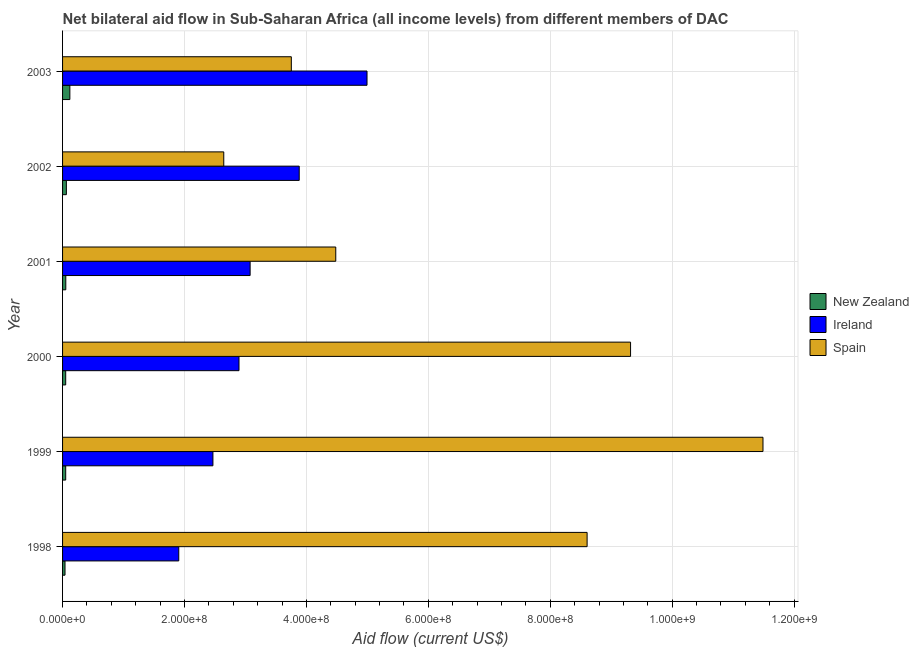How many bars are there on the 3rd tick from the bottom?
Your answer should be compact. 3. What is the label of the 5th group of bars from the top?
Offer a very short reply. 1999. What is the amount of aid provided by new zealand in 1999?
Ensure brevity in your answer.  5.15e+06. Across all years, what is the maximum amount of aid provided by new zealand?
Give a very brief answer. 1.20e+07. Across all years, what is the minimum amount of aid provided by ireland?
Offer a very short reply. 1.91e+08. In which year was the amount of aid provided by spain maximum?
Provide a succinct answer. 1999. What is the total amount of aid provided by ireland in the graph?
Provide a succinct answer. 1.92e+09. What is the difference between the amount of aid provided by ireland in 1999 and that in 2003?
Your answer should be very brief. -2.53e+08. What is the difference between the amount of aid provided by ireland in 2000 and the amount of aid provided by spain in 2002?
Ensure brevity in your answer.  2.50e+07. What is the average amount of aid provided by new zealand per year?
Your response must be concise. 6.30e+06. In the year 1998, what is the difference between the amount of aid provided by ireland and amount of aid provided by new zealand?
Your response must be concise. 1.87e+08. What is the ratio of the amount of aid provided by new zealand in 1999 to that in 2000?
Keep it short and to the point. 1. Is the difference between the amount of aid provided by ireland in 2001 and 2003 greater than the difference between the amount of aid provided by new zealand in 2001 and 2003?
Make the answer very short. No. What is the difference between the highest and the second highest amount of aid provided by spain?
Your answer should be compact. 2.17e+08. What is the difference between the highest and the lowest amount of aid provided by new zealand?
Your answer should be compact. 7.94e+06. In how many years, is the amount of aid provided by ireland greater than the average amount of aid provided by ireland taken over all years?
Offer a very short reply. 2. Is the sum of the amount of aid provided by new zealand in 1998 and 1999 greater than the maximum amount of aid provided by ireland across all years?
Keep it short and to the point. No. What does the 1st bar from the bottom in 1998 represents?
Make the answer very short. New Zealand. Is it the case that in every year, the sum of the amount of aid provided by new zealand and amount of aid provided by ireland is greater than the amount of aid provided by spain?
Provide a short and direct response. No. What is the difference between two consecutive major ticks on the X-axis?
Give a very brief answer. 2.00e+08. Does the graph contain grids?
Keep it short and to the point. Yes. How are the legend labels stacked?
Your answer should be very brief. Vertical. What is the title of the graph?
Ensure brevity in your answer.  Net bilateral aid flow in Sub-Saharan Africa (all income levels) from different members of DAC. What is the label or title of the X-axis?
Provide a short and direct response. Aid flow (current US$). What is the Aid flow (current US$) of New Zealand in 1998?
Ensure brevity in your answer.  4.02e+06. What is the Aid flow (current US$) in Ireland in 1998?
Keep it short and to the point. 1.91e+08. What is the Aid flow (current US$) in Spain in 1998?
Your answer should be very brief. 8.60e+08. What is the Aid flow (current US$) in New Zealand in 1999?
Your answer should be compact. 5.15e+06. What is the Aid flow (current US$) of Ireland in 1999?
Give a very brief answer. 2.47e+08. What is the Aid flow (current US$) of Spain in 1999?
Give a very brief answer. 1.15e+09. What is the Aid flow (current US$) in New Zealand in 2000?
Your answer should be compact. 5.14e+06. What is the Aid flow (current US$) of Ireland in 2000?
Give a very brief answer. 2.89e+08. What is the Aid flow (current US$) in Spain in 2000?
Ensure brevity in your answer.  9.32e+08. What is the Aid flow (current US$) of New Zealand in 2001?
Give a very brief answer. 5.29e+06. What is the Aid flow (current US$) in Ireland in 2001?
Your response must be concise. 3.08e+08. What is the Aid flow (current US$) in Spain in 2001?
Provide a succinct answer. 4.48e+08. What is the Aid flow (current US$) of New Zealand in 2002?
Ensure brevity in your answer.  6.26e+06. What is the Aid flow (current US$) in Ireland in 2002?
Make the answer very short. 3.88e+08. What is the Aid flow (current US$) in Spain in 2002?
Ensure brevity in your answer.  2.64e+08. What is the Aid flow (current US$) in New Zealand in 2003?
Offer a very short reply. 1.20e+07. What is the Aid flow (current US$) in Ireland in 2003?
Offer a very short reply. 4.99e+08. What is the Aid flow (current US$) of Spain in 2003?
Give a very brief answer. 3.75e+08. Across all years, what is the maximum Aid flow (current US$) of New Zealand?
Keep it short and to the point. 1.20e+07. Across all years, what is the maximum Aid flow (current US$) of Ireland?
Ensure brevity in your answer.  4.99e+08. Across all years, what is the maximum Aid flow (current US$) in Spain?
Your answer should be very brief. 1.15e+09. Across all years, what is the minimum Aid flow (current US$) in New Zealand?
Offer a very short reply. 4.02e+06. Across all years, what is the minimum Aid flow (current US$) of Ireland?
Offer a very short reply. 1.91e+08. Across all years, what is the minimum Aid flow (current US$) of Spain?
Give a very brief answer. 2.64e+08. What is the total Aid flow (current US$) in New Zealand in the graph?
Offer a very short reply. 3.78e+07. What is the total Aid flow (current US$) of Ireland in the graph?
Provide a succinct answer. 1.92e+09. What is the total Aid flow (current US$) in Spain in the graph?
Provide a succinct answer. 4.03e+09. What is the difference between the Aid flow (current US$) of New Zealand in 1998 and that in 1999?
Your response must be concise. -1.13e+06. What is the difference between the Aid flow (current US$) in Ireland in 1998 and that in 1999?
Provide a succinct answer. -5.60e+07. What is the difference between the Aid flow (current US$) of Spain in 1998 and that in 1999?
Offer a terse response. -2.88e+08. What is the difference between the Aid flow (current US$) in New Zealand in 1998 and that in 2000?
Make the answer very short. -1.12e+06. What is the difference between the Aid flow (current US$) of Ireland in 1998 and that in 2000?
Keep it short and to the point. -9.88e+07. What is the difference between the Aid flow (current US$) in Spain in 1998 and that in 2000?
Keep it short and to the point. -7.13e+07. What is the difference between the Aid flow (current US$) in New Zealand in 1998 and that in 2001?
Offer a very short reply. -1.27e+06. What is the difference between the Aid flow (current US$) of Ireland in 1998 and that in 2001?
Provide a succinct answer. -1.17e+08. What is the difference between the Aid flow (current US$) in Spain in 1998 and that in 2001?
Provide a succinct answer. 4.12e+08. What is the difference between the Aid flow (current US$) in New Zealand in 1998 and that in 2002?
Offer a very short reply. -2.24e+06. What is the difference between the Aid flow (current US$) in Ireland in 1998 and that in 2002?
Ensure brevity in your answer.  -1.98e+08. What is the difference between the Aid flow (current US$) of Spain in 1998 and that in 2002?
Make the answer very short. 5.96e+08. What is the difference between the Aid flow (current US$) in New Zealand in 1998 and that in 2003?
Provide a succinct answer. -7.94e+06. What is the difference between the Aid flow (current US$) in Ireland in 1998 and that in 2003?
Ensure brevity in your answer.  -3.09e+08. What is the difference between the Aid flow (current US$) in Spain in 1998 and that in 2003?
Your answer should be very brief. 4.85e+08. What is the difference between the Aid flow (current US$) of New Zealand in 1999 and that in 2000?
Offer a terse response. 10000. What is the difference between the Aid flow (current US$) in Ireland in 1999 and that in 2000?
Keep it short and to the point. -4.28e+07. What is the difference between the Aid flow (current US$) of Spain in 1999 and that in 2000?
Your answer should be compact. 2.17e+08. What is the difference between the Aid flow (current US$) of Ireland in 1999 and that in 2001?
Provide a short and direct response. -6.10e+07. What is the difference between the Aid flow (current US$) in Spain in 1999 and that in 2001?
Offer a terse response. 7.01e+08. What is the difference between the Aid flow (current US$) of New Zealand in 1999 and that in 2002?
Offer a terse response. -1.11e+06. What is the difference between the Aid flow (current US$) of Ireland in 1999 and that in 2002?
Offer a very short reply. -1.42e+08. What is the difference between the Aid flow (current US$) in Spain in 1999 and that in 2002?
Your response must be concise. 8.84e+08. What is the difference between the Aid flow (current US$) of New Zealand in 1999 and that in 2003?
Make the answer very short. -6.81e+06. What is the difference between the Aid flow (current US$) in Ireland in 1999 and that in 2003?
Provide a short and direct response. -2.53e+08. What is the difference between the Aid flow (current US$) of Spain in 1999 and that in 2003?
Offer a terse response. 7.74e+08. What is the difference between the Aid flow (current US$) of New Zealand in 2000 and that in 2001?
Make the answer very short. -1.50e+05. What is the difference between the Aid flow (current US$) in Ireland in 2000 and that in 2001?
Ensure brevity in your answer.  -1.82e+07. What is the difference between the Aid flow (current US$) of Spain in 2000 and that in 2001?
Provide a short and direct response. 4.84e+08. What is the difference between the Aid flow (current US$) of New Zealand in 2000 and that in 2002?
Provide a short and direct response. -1.12e+06. What is the difference between the Aid flow (current US$) in Ireland in 2000 and that in 2002?
Provide a short and direct response. -9.88e+07. What is the difference between the Aid flow (current US$) in Spain in 2000 and that in 2002?
Your answer should be very brief. 6.67e+08. What is the difference between the Aid flow (current US$) of New Zealand in 2000 and that in 2003?
Your answer should be very brief. -6.82e+06. What is the difference between the Aid flow (current US$) of Ireland in 2000 and that in 2003?
Keep it short and to the point. -2.10e+08. What is the difference between the Aid flow (current US$) of Spain in 2000 and that in 2003?
Keep it short and to the point. 5.56e+08. What is the difference between the Aid flow (current US$) of New Zealand in 2001 and that in 2002?
Provide a succinct answer. -9.70e+05. What is the difference between the Aid flow (current US$) in Ireland in 2001 and that in 2002?
Your answer should be compact. -8.05e+07. What is the difference between the Aid flow (current US$) in Spain in 2001 and that in 2002?
Ensure brevity in your answer.  1.84e+08. What is the difference between the Aid flow (current US$) of New Zealand in 2001 and that in 2003?
Offer a very short reply. -6.67e+06. What is the difference between the Aid flow (current US$) of Ireland in 2001 and that in 2003?
Make the answer very short. -1.92e+08. What is the difference between the Aid flow (current US$) in Spain in 2001 and that in 2003?
Your answer should be compact. 7.29e+07. What is the difference between the Aid flow (current US$) in New Zealand in 2002 and that in 2003?
Ensure brevity in your answer.  -5.70e+06. What is the difference between the Aid flow (current US$) in Ireland in 2002 and that in 2003?
Your answer should be very brief. -1.11e+08. What is the difference between the Aid flow (current US$) in Spain in 2002 and that in 2003?
Keep it short and to the point. -1.11e+08. What is the difference between the Aid flow (current US$) in New Zealand in 1998 and the Aid flow (current US$) in Ireland in 1999?
Offer a very short reply. -2.43e+08. What is the difference between the Aid flow (current US$) in New Zealand in 1998 and the Aid flow (current US$) in Spain in 1999?
Provide a short and direct response. -1.14e+09. What is the difference between the Aid flow (current US$) in Ireland in 1998 and the Aid flow (current US$) in Spain in 1999?
Give a very brief answer. -9.58e+08. What is the difference between the Aid flow (current US$) in New Zealand in 1998 and the Aid flow (current US$) in Ireland in 2000?
Your answer should be very brief. -2.85e+08. What is the difference between the Aid flow (current US$) in New Zealand in 1998 and the Aid flow (current US$) in Spain in 2000?
Provide a succinct answer. -9.28e+08. What is the difference between the Aid flow (current US$) of Ireland in 1998 and the Aid flow (current US$) of Spain in 2000?
Give a very brief answer. -7.41e+08. What is the difference between the Aid flow (current US$) in New Zealand in 1998 and the Aid flow (current US$) in Ireland in 2001?
Provide a short and direct response. -3.04e+08. What is the difference between the Aid flow (current US$) of New Zealand in 1998 and the Aid flow (current US$) of Spain in 2001?
Keep it short and to the point. -4.44e+08. What is the difference between the Aid flow (current US$) in Ireland in 1998 and the Aid flow (current US$) in Spain in 2001?
Your answer should be compact. -2.58e+08. What is the difference between the Aid flow (current US$) of New Zealand in 1998 and the Aid flow (current US$) of Ireland in 2002?
Keep it short and to the point. -3.84e+08. What is the difference between the Aid flow (current US$) in New Zealand in 1998 and the Aid flow (current US$) in Spain in 2002?
Your answer should be compact. -2.60e+08. What is the difference between the Aid flow (current US$) of Ireland in 1998 and the Aid flow (current US$) of Spain in 2002?
Keep it short and to the point. -7.38e+07. What is the difference between the Aid flow (current US$) in New Zealand in 1998 and the Aid flow (current US$) in Ireland in 2003?
Give a very brief answer. -4.95e+08. What is the difference between the Aid flow (current US$) of New Zealand in 1998 and the Aid flow (current US$) of Spain in 2003?
Your answer should be compact. -3.71e+08. What is the difference between the Aid flow (current US$) of Ireland in 1998 and the Aid flow (current US$) of Spain in 2003?
Ensure brevity in your answer.  -1.85e+08. What is the difference between the Aid flow (current US$) of New Zealand in 1999 and the Aid flow (current US$) of Ireland in 2000?
Offer a terse response. -2.84e+08. What is the difference between the Aid flow (current US$) of New Zealand in 1999 and the Aid flow (current US$) of Spain in 2000?
Ensure brevity in your answer.  -9.27e+08. What is the difference between the Aid flow (current US$) of Ireland in 1999 and the Aid flow (current US$) of Spain in 2000?
Offer a terse response. -6.85e+08. What is the difference between the Aid flow (current US$) of New Zealand in 1999 and the Aid flow (current US$) of Ireland in 2001?
Ensure brevity in your answer.  -3.03e+08. What is the difference between the Aid flow (current US$) of New Zealand in 1999 and the Aid flow (current US$) of Spain in 2001?
Your response must be concise. -4.43e+08. What is the difference between the Aid flow (current US$) in Ireland in 1999 and the Aid flow (current US$) in Spain in 2001?
Make the answer very short. -2.02e+08. What is the difference between the Aid flow (current US$) of New Zealand in 1999 and the Aid flow (current US$) of Ireland in 2002?
Offer a terse response. -3.83e+08. What is the difference between the Aid flow (current US$) in New Zealand in 1999 and the Aid flow (current US$) in Spain in 2002?
Provide a short and direct response. -2.59e+08. What is the difference between the Aid flow (current US$) in Ireland in 1999 and the Aid flow (current US$) in Spain in 2002?
Your answer should be very brief. -1.78e+07. What is the difference between the Aid flow (current US$) in New Zealand in 1999 and the Aid flow (current US$) in Ireland in 2003?
Your answer should be compact. -4.94e+08. What is the difference between the Aid flow (current US$) in New Zealand in 1999 and the Aid flow (current US$) in Spain in 2003?
Offer a terse response. -3.70e+08. What is the difference between the Aid flow (current US$) of Ireland in 1999 and the Aid flow (current US$) of Spain in 2003?
Offer a terse response. -1.29e+08. What is the difference between the Aid flow (current US$) of New Zealand in 2000 and the Aid flow (current US$) of Ireland in 2001?
Keep it short and to the point. -3.03e+08. What is the difference between the Aid flow (current US$) in New Zealand in 2000 and the Aid flow (current US$) in Spain in 2001?
Offer a terse response. -4.43e+08. What is the difference between the Aid flow (current US$) in Ireland in 2000 and the Aid flow (current US$) in Spain in 2001?
Offer a terse response. -1.59e+08. What is the difference between the Aid flow (current US$) of New Zealand in 2000 and the Aid flow (current US$) of Ireland in 2002?
Ensure brevity in your answer.  -3.83e+08. What is the difference between the Aid flow (current US$) of New Zealand in 2000 and the Aid flow (current US$) of Spain in 2002?
Ensure brevity in your answer.  -2.59e+08. What is the difference between the Aid flow (current US$) in Ireland in 2000 and the Aid flow (current US$) in Spain in 2002?
Your answer should be very brief. 2.50e+07. What is the difference between the Aid flow (current US$) of New Zealand in 2000 and the Aid flow (current US$) of Ireland in 2003?
Provide a short and direct response. -4.94e+08. What is the difference between the Aid flow (current US$) of New Zealand in 2000 and the Aid flow (current US$) of Spain in 2003?
Keep it short and to the point. -3.70e+08. What is the difference between the Aid flow (current US$) in Ireland in 2000 and the Aid flow (current US$) in Spain in 2003?
Ensure brevity in your answer.  -8.58e+07. What is the difference between the Aid flow (current US$) of New Zealand in 2001 and the Aid flow (current US$) of Ireland in 2002?
Your answer should be very brief. -3.83e+08. What is the difference between the Aid flow (current US$) of New Zealand in 2001 and the Aid flow (current US$) of Spain in 2002?
Your answer should be compact. -2.59e+08. What is the difference between the Aid flow (current US$) of Ireland in 2001 and the Aid flow (current US$) of Spain in 2002?
Your answer should be very brief. 4.32e+07. What is the difference between the Aid flow (current US$) in New Zealand in 2001 and the Aid flow (current US$) in Ireland in 2003?
Your answer should be very brief. -4.94e+08. What is the difference between the Aid flow (current US$) of New Zealand in 2001 and the Aid flow (current US$) of Spain in 2003?
Keep it short and to the point. -3.70e+08. What is the difference between the Aid flow (current US$) in Ireland in 2001 and the Aid flow (current US$) in Spain in 2003?
Ensure brevity in your answer.  -6.76e+07. What is the difference between the Aid flow (current US$) of New Zealand in 2002 and the Aid flow (current US$) of Ireland in 2003?
Offer a very short reply. -4.93e+08. What is the difference between the Aid flow (current US$) in New Zealand in 2002 and the Aid flow (current US$) in Spain in 2003?
Provide a succinct answer. -3.69e+08. What is the difference between the Aid flow (current US$) in Ireland in 2002 and the Aid flow (current US$) in Spain in 2003?
Offer a terse response. 1.30e+07. What is the average Aid flow (current US$) in New Zealand per year?
Your answer should be compact. 6.30e+06. What is the average Aid flow (current US$) in Ireland per year?
Provide a succinct answer. 3.20e+08. What is the average Aid flow (current US$) of Spain per year?
Offer a terse response. 6.71e+08. In the year 1998, what is the difference between the Aid flow (current US$) of New Zealand and Aid flow (current US$) of Ireland?
Provide a short and direct response. -1.87e+08. In the year 1998, what is the difference between the Aid flow (current US$) in New Zealand and Aid flow (current US$) in Spain?
Your response must be concise. -8.56e+08. In the year 1998, what is the difference between the Aid flow (current US$) in Ireland and Aid flow (current US$) in Spain?
Provide a succinct answer. -6.70e+08. In the year 1999, what is the difference between the Aid flow (current US$) of New Zealand and Aid flow (current US$) of Ireland?
Offer a very short reply. -2.41e+08. In the year 1999, what is the difference between the Aid flow (current US$) in New Zealand and Aid flow (current US$) in Spain?
Give a very brief answer. -1.14e+09. In the year 1999, what is the difference between the Aid flow (current US$) of Ireland and Aid flow (current US$) of Spain?
Give a very brief answer. -9.02e+08. In the year 2000, what is the difference between the Aid flow (current US$) in New Zealand and Aid flow (current US$) in Ireland?
Your response must be concise. -2.84e+08. In the year 2000, what is the difference between the Aid flow (current US$) in New Zealand and Aid flow (current US$) in Spain?
Make the answer very short. -9.27e+08. In the year 2000, what is the difference between the Aid flow (current US$) of Ireland and Aid flow (current US$) of Spain?
Give a very brief answer. -6.42e+08. In the year 2001, what is the difference between the Aid flow (current US$) of New Zealand and Aid flow (current US$) of Ireland?
Offer a very short reply. -3.02e+08. In the year 2001, what is the difference between the Aid flow (current US$) of New Zealand and Aid flow (current US$) of Spain?
Provide a succinct answer. -4.43e+08. In the year 2001, what is the difference between the Aid flow (current US$) of Ireland and Aid flow (current US$) of Spain?
Offer a very short reply. -1.40e+08. In the year 2002, what is the difference between the Aid flow (current US$) in New Zealand and Aid flow (current US$) in Ireland?
Offer a very short reply. -3.82e+08. In the year 2002, what is the difference between the Aid flow (current US$) of New Zealand and Aid flow (current US$) of Spain?
Your answer should be compact. -2.58e+08. In the year 2002, what is the difference between the Aid flow (current US$) of Ireland and Aid flow (current US$) of Spain?
Offer a very short reply. 1.24e+08. In the year 2003, what is the difference between the Aid flow (current US$) in New Zealand and Aid flow (current US$) in Ireland?
Provide a short and direct response. -4.87e+08. In the year 2003, what is the difference between the Aid flow (current US$) of New Zealand and Aid flow (current US$) of Spain?
Ensure brevity in your answer.  -3.63e+08. In the year 2003, what is the difference between the Aid flow (current US$) in Ireland and Aid flow (current US$) in Spain?
Offer a very short reply. 1.24e+08. What is the ratio of the Aid flow (current US$) of New Zealand in 1998 to that in 1999?
Offer a terse response. 0.78. What is the ratio of the Aid flow (current US$) of Ireland in 1998 to that in 1999?
Give a very brief answer. 0.77. What is the ratio of the Aid flow (current US$) of Spain in 1998 to that in 1999?
Offer a very short reply. 0.75. What is the ratio of the Aid flow (current US$) in New Zealand in 1998 to that in 2000?
Your response must be concise. 0.78. What is the ratio of the Aid flow (current US$) in Ireland in 1998 to that in 2000?
Offer a very short reply. 0.66. What is the ratio of the Aid flow (current US$) of Spain in 1998 to that in 2000?
Offer a very short reply. 0.92. What is the ratio of the Aid flow (current US$) of New Zealand in 1998 to that in 2001?
Keep it short and to the point. 0.76. What is the ratio of the Aid flow (current US$) of Ireland in 1998 to that in 2001?
Give a very brief answer. 0.62. What is the ratio of the Aid flow (current US$) of Spain in 1998 to that in 2001?
Your answer should be compact. 1.92. What is the ratio of the Aid flow (current US$) of New Zealand in 1998 to that in 2002?
Your answer should be very brief. 0.64. What is the ratio of the Aid flow (current US$) in Ireland in 1998 to that in 2002?
Provide a succinct answer. 0.49. What is the ratio of the Aid flow (current US$) in Spain in 1998 to that in 2002?
Ensure brevity in your answer.  3.25. What is the ratio of the Aid flow (current US$) in New Zealand in 1998 to that in 2003?
Offer a terse response. 0.34. What is the ratio of the Aid flow (current US$) in Ireland in 1998 to that in 2003?
Offer a terse response. 0.38. What is the ratio of the Aid flow (current US$) of Spain in 1998 to that in 2003?
Your answer should be compact. 2.29. What is the ratio of the Aid flow (current US$) in Ireland in 1999 to that in 2000?
Give a very brief answer. 0.85. What is the ratio of the Aid flow (current US$) in Spain in 1999 to that in 2000?
Make the answer very short. 1.23. What is the ratio of the Aid flow (current US$) in New Zealand in 1999 to that in 2001?
Provide a short and direct response. 0.97. What is the ratio of the Aid flow (current US$) of Ireland in 1999 to that in 2001?
Give a very brief answer. 0.8. What is the ratio of the Aid flow (current US$) of Spain in 1999 to that in 2001?
Offer a terse response. 2.56. What is the ratio of the Aid flow (current US$) of New Zealand in 1999 to that in 2002?
Keep it short and to the point. 0.82. What is the ratio of the Aid flow (current US$) of Ireland in 1999 to that in 2002?
Provide a succinct answer. 0.64. What is the ratio of the Aid flow (current US$) in Spain in 1999 to that in 2002?
Ensure brevity in your answer.  4.34. What is the ratio of the Aid flow (current US$) in New Zealand in 1999 to that in 2003?
Make the answer very short. 0.43. What is the ratio of the Aid flow (current US$) in Ireland in 1999 to that in 2003?
Your response must be concise. 0.49. What is the ratio of the Aid flow (current US$) in Spain in 1999 to that in 2003?
Ensure brevity in your answer.  3.06. What is the ratio of the Aid flow (current US$) of New Zealand in 2000 to that in 2001?
Make the answer very short. 0.97. What is the ratio of the Aid flow (current US$) of Ireland in 2000 to that in 2001?
Offer a very short reply. 0.94. What is the ratio of the Aid flow (current US$) of Spain in 2000 to that in 2001?
Offer a very short reply. 2.08. What is the ratio of the Aid flow (current US$) of New Zealand in 2000 to that in 2002?
Your answer should be compact. 0.82. What is the ratio of the Aid flow (current US$) of Ireland in 2000 to that in 2002?
Your answer should be very brief. 0.75. What is the ratio of the Aid flow (current US$) of Spain in 2000 to that in 2002?
Offer a terse response. 3.52. What is the ratio of the Aid flow (current US$) of New Zealand in 2000 to that in 2003?
Your response must be concise. 0.43. What is the ratio of the Aid flow (current US$) of Ireland in 2000 to that in 2003?
Offer a terse response. 0.58. What is the ratio of the Aid flow (current US$) in Spain in 2000 to that in 2003?
Provide a succinct answer. 2.48. What is the ratio of the Aid flow (current US$) in New Zealand in 2001 to that in 2002?
Offer a very short reply. 0.84. What is the ratio of the Aid flow (current US$) in Ireland in 2001 to that in 2002?
Offer a very short reply. 0.79. What is the ratio of the Aid flow (current US$) in Spain in 2001 to that in 2002?
Offer a terse response. 1.69. What is the ratio of the Aid flow (current US$) of New Zealand in 2001 to that in 2003?
Ensure brevity in your answer.  0.44. What is the ratio of the Aid flow (current US$) of Ireland in 2001 to that in 2003?
Provide a succinct answer. 0.62. What is the ratio of the Aid flow (current US$) in Spain in 2001 to that in 2003?
Your answer should be compact. 1.19. What is the ratio of the Aid flow (current US$) of New Zealand in 2002 to that in 2003?
Your response must be concise. 0.52. What is the ratio of the Aid flow (current US$) of Ireland in 2002 to that in 2003?
Your answer should be compact. 0.78. What is the ratio of the Aid flow (current US$) in Spain in 2002 to that in 2003?
Keep it short and to the point. 0.7. What is the difference between the highest and the second highest Aid flow (current US$) in New Zealand?
Offer a very short reply. 5.70e+06. What is the difference between the highest and the second highest Aid flow (current US$) in Ireland?
Offer a very short reply. 1.11e+08. What is the difference between the highest and the second highest Aid flow (current US$) in Spain?
Provide a succinct answer. 2.17e+08. What is the difference between the highest and the lowest Aid flow (current US$) in New Zealand?
Give a very brief answer. 7.94e+06. What is the difference between the highest and the lowest Aid flow (current US$) in Ireland?
Keep it short and to the point. 3.09e+08. What is the difference between the highest and the lowest Aid flow (current US$) in Spain?
Your response must be concise. 8.84e+08. 